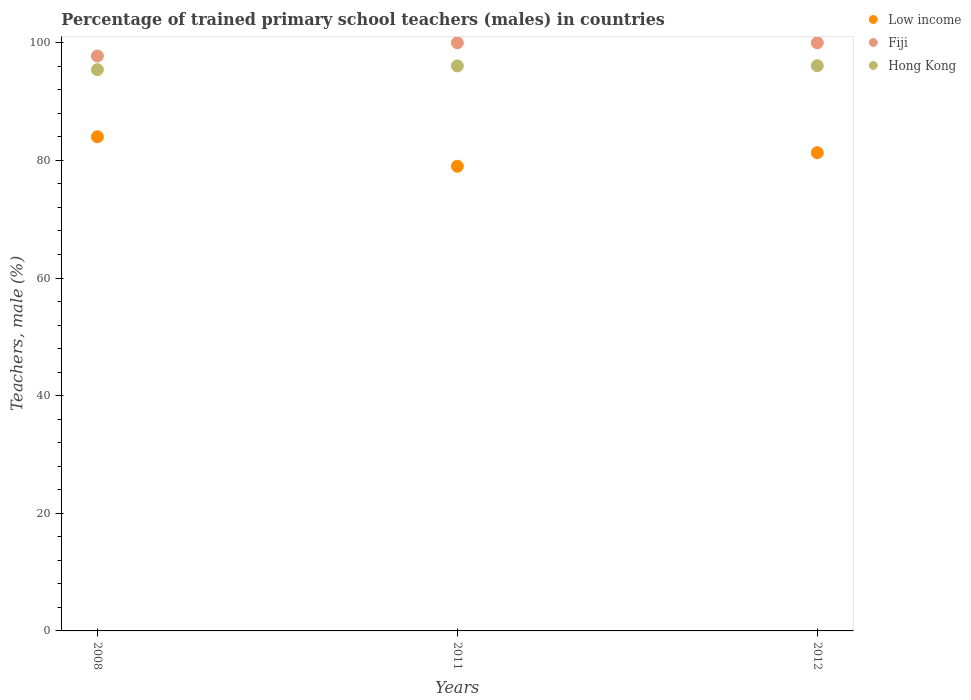Is the number of dotlines equal to the number of legend labels?
Give a very brief answer. Yes. What is the percentage of trained primary school teachers (males) in Hong Kong in 2012?
Keep it short and to the point. 96.1. Across all years, what is the maximum percentage of trained primary school teachers (males) in Low income?
Your answer should be very brief. 84.02. Across all years, what is the minimum percentage of trained primary school teachers (males) in Hong Kong?
Your answer should be very brief. 95.42. In which year was the percentage of trained primary school teachers (males) in Low income maximum?
Provide a succinct answer. 2008. In which year was the percentage of trained primary school teachers (males) in Hong Kong minimum?
Offer a terse response. 2008. What is the total percentage of trained primary school teachers (males) in Fiji in the graph?
Ensure brevity in your answer.  297.75. What is the difference between the percentage of trained primary school teachers (males) in Fiji in 2008 and that in 2012?
Give a very brief answer. -2.25. What is the difference between the percentage of trained primary school teachers (males) in Low income in 2012 and the percentage of trained primary school teachers (males) in Hong Kong in 2008?
Provide a succinct answer. -14.12. What is the average percentage of trained primary school teachers (males) in Low income per year?
Give a very brief answer. 81.44. In the year 2008, what is the difference between the percentage of trained primary school teachers (males) in Fiji and percentage of trained primary school teachers (males) in Low income?
Ensure brevity in your answer.  13.73. What is the ratio of the percentage of trained primary school teachers (males) in Low income in 2008 to that in 2012?
Make the answer very short. 1.03. Is the percentage of trained primary school teachers (males) in Hong Kong in 2008 less than that in 2011?
Provide a short and direct response. Yes. What is the difference between the highest and the second highest percentage of trained primary school teachers (males) in Hong Kong?
Your answer should be compact. 0.03. What is the difference between the highest and the lowest percentage of trained primary school teachers (males) in Fiji?
Provide a succinct answer. 2.25. Is the sum of the percentage of trained primary school teachers (males) in Fiji in 2011 and 2012 greater than the maximum percentage of trained primary school teachers (males) in Low income across all years?
Your answer should be very brief. Yes. Is it the case that in every year, the sum of the percentage of trained primary school teachers (males) in Hong Kong and percentage of trained primary school teachers (males) in Fiji  is greater than the percentage of trained primary school teachers (males) in Low income?
Provide a short and direct response. Yes. Is the percentage of trained primary school teachers (males) in Low income strictly greater than the percentage of trained primary school teachers (males) in Fiji over the years?
Provide a short and direct response. No. How many years are there in the graph?
Ensure brevity in your answer.  3. How are the legend labels stacked?
Offer a terse response. Vertical. What is the title of the graph?
Your answer should be compact. Percentage of trained primary school teachers (males) in countries. Does "Liberia" appear as one of the legend labels in the graph?
Your answer should be very brief. No. What is the label or title of the X-axis?
Keep it short and to the point. Years. What is the label or title of the Y-axis?
Offer a very short reply. Teachers, male (%). What is the Teachers, male (%) of Low income in 2008?
Offer a terse response. 84.02. What is the Teachers, male (%) in Fiji in 2008?
Provide a succinct answer. 97.75. What is the Teachers, male (%) of Hong Kong in 2008?
Your answer should be compact. 95.42. What is the Teachers, male (%) of Low income in 2011?
Your answer should be very brief. 79. What is the Teachers, male (%) of Fiji in 2011?
Your response must be concise. 100. What is the Teachers, male (%) in Hong Kong in 2011?
Provide a short and direct response. 96.06. What is the Teachers, male (%) in Low income in 2012?
Ensure brevity in your answer.  81.31. What is the Teachers, male (%) in Hong Kong in 2012?
Make the answer very short. 96.1. Across all years, what is the maximum Teachers, male (%) of Low income?
Provide a succinct answer. 84.02. Across all years, what is the maximum Teachers, male (%) of Hong Kong?
Offer a very short reply. 96.1. Across all years, what is the minimum Teachers, male (%) in Low income?
Your answer should be very brief. 79. Across all years, what is the minimum Teachers, male (%) of Fiji?
Offer a very short reply. 97.75. Across all years, what is the minimum Teachers, male (%) of Hong Kong?
Provide a short and direct response. 95.42. What is the total Teachers, male (%) in Low income in the graph?
Provide a succinct answer. 244.33. What is the total Teachers, male (%) of Fiji in the graph?
Offer a very short reply. 297.75. What is the total Teachers, male (%) of Hong Kong in the graph?
Offer a terse response. 287.58. What is the difference between the Teachers, male (%) of Low income in 2008 and that in 2011?
Your answer should be compact. 5.02. What is the difference between the Teachers, male (%) of Fiji in 2008 and that in 2011?
Provide a succinct answer. -2.25. What is the difference between the Teachers, male (%) in Hong Kong in 2008 and that in 2011?
Your response must be concise. -0.64. What is the difference between the Teachers, male (%) in Low income in 2008 and that in 2012?
Give a very brief answer. 2.71. What is the difference between the Teachers, male (%) of Fiji in 2008 and that in 2012?
Offer a terse response. -2.25. What is the difference between the Teachers, male (%) in Hong Kong in 2008 and that in 2012?
Your response must be concise. -0.67. What is the difference between the Teachers, male (%) of Low income in 2011 and that in 2012?
Offer a very short reply. -2.31. What is the difference between the Teachers, male (%) of Hong Kong in 2011 and that in 2012?
Ensure brevity in your answer.  -0.03. What is the difference between the Teachers, male (%) of Low income in 2008 and the Teachers, male (%) of Fiji in 2011?
Offer a very short reply. -15.98. What is the difference between the Teachers, male (%) of Low income in 2008 and the Teachers, male (%) of Hong Kong in 2011?
Your response must be concise. -12.04. What is the difference between the Teachers, male (%) of Fiji in 2008 and the Teachers, male (%) of Hong Kong in 2011?
Give a very brief answer. 1.68. What is the difference between the Teachers, male (%) of Low income in 2008 and the Teachers, male (%) of Fiji in 2012?
Make the answer very short. -15.98. What is the difference between the Teachers, male (%) in Low income in 2008 and the Teachers, male (%) in Hong Kong in 2012?
Provide a short and direct response. -12.08. What is the difference between the Teachers, male (%) in Fiji in 2008 and the Teachers, male (%) in Hong Kong in 2012?
Keep it short and to the point. 1.65. What is the difference between the Teachers, male (%) of Low income in 2011 and the Teachers, male (%) of Fiji in 2012?
Offer a very short reply. -21. What is the difference between the Teachers, male (%) in Low income in 2011 and the Teachers, male (%) in Hong Kong in 2012?
Make the answer very short. -17.1. What is the difference between the Teachers, male (%) in Fiji in 2011 and the Teachers, male (%) in Hong Kong in 2012?
Provide a succinct answer. 3.9. What is the average Teachers, male (%) in Low income per year?
Offer a terse response. 81.44. What is the average Teachers, male (%) in Fiji per year?
Keep it short and to the point. 99.25. What is the average Teachers, male (%) of Hong Kong per year?
Offer a terse response. 95.86. In the year 2008, what is the difference between the Teachers, male (%) in Low income and Teachers, male (%) in Fiji?
Offer a terse response. -13.73. In the year 2008, what is the difference between the Teachers, male (%) in Low income and Teachers, male (%) in Hong Kong?
Your response must be concise. -11.4. In the year 2008, what is the difference between the Teachers, male (%) in Fiji and Teachers, male (%) in Hong Kong?
Ensure brevity in your answer.  2.32. In the year 2011, what is the difference between the Teachers, male (%) in Low income and Teachers, male (%) in Fiji?
Offer a very short reply. -21. In the year 2011, what is the difference between the Teachers, male (%) in Low income and Teachers, male (%) in Hong Kong?
Give a very brief answer. -17.06. In the year 2011, what is the difference between the Teachers, male (%) in Fiji and Teachers, male (%) in Hong Kong?
Make the answer very short. 3.94. In the year 2012, what is the difference between the Teachers, male (%) of Low income and Teachers, male (%) of Fiji?
Your answer should be compact. -18.69. In the year 2012, what is the difference between the Teachers, male (%) in Low income and Teachers, male (%) in Hong Kong?
Give a very brief answer. -14.79. In the year 2012, what is the difference between the Teachers, male (%) of Fiji and Teachers, male (%) of Hong Kong?
Offer a terse response. 3.9. What is the ratio of the Teachers, male (%) in Low income in 2008 to that in 2011?
Your answer should be very brief. 1.06. What is the ratio of the Teachers, male (%) of Fiji in 2008 to that in 2011?
Offer a very short reply. 0.98. What is the ratio of the Teachers, male (%) of Low income in 2008 to that in 2012?
Your answer should be compact. 1.03. What is the ratio of the Teachers, male (%) of Fiji in 2008 to that in 2012?
Provide a short and direct response. 0.98. What is the ratio of the Teachers, male (%) of Low income in 2011 to that in 2012?
Offer a terse response. 0.97. What is the ratio of the Teachers, male (%) of Hong Kong in 2011 to that in 2012?
Provide a short and direct response. 1. What is the difference between the highest and the second highest Teachers, male (%) of Low income?
Your answer should be very brief. 2.71. What is the difference between the highest and the second highest Teachers, male (%) of Hong Kong?
Your answer should be compact. 0.03. What is the difference between the highest and the lowest Teachers, male (%) in Low income?
Your answer should be compact. 5.02. What is the difference between the highest and the lowest Teachers, male (%) in Fiji?
Provide a short and direct response. 2.25. What is the difference between the highest and the lowest Teachers, male (%) of Hong Kong?
Offer a very short reply. 0.67. 